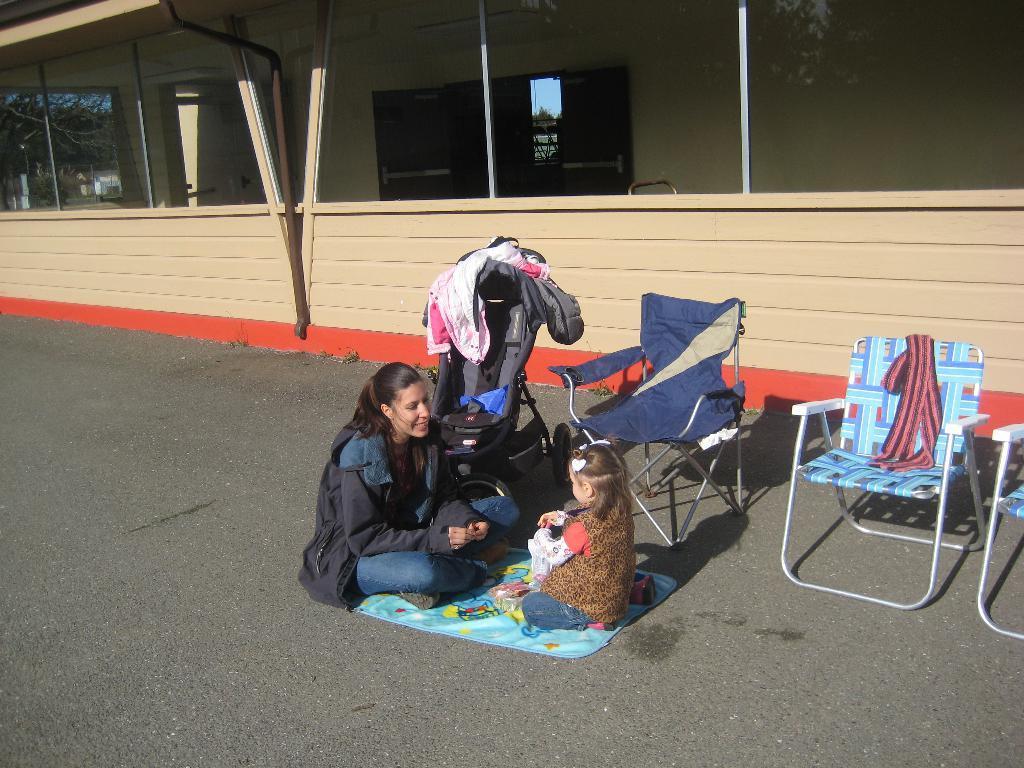How would you summarize this image in a sentence or two? In the image we can see there are people who are sitting on road and they had spread the cloth and they are sitting over it. There are chairs and there is a buggy on which there is a jacket kept and beside there is a building. 